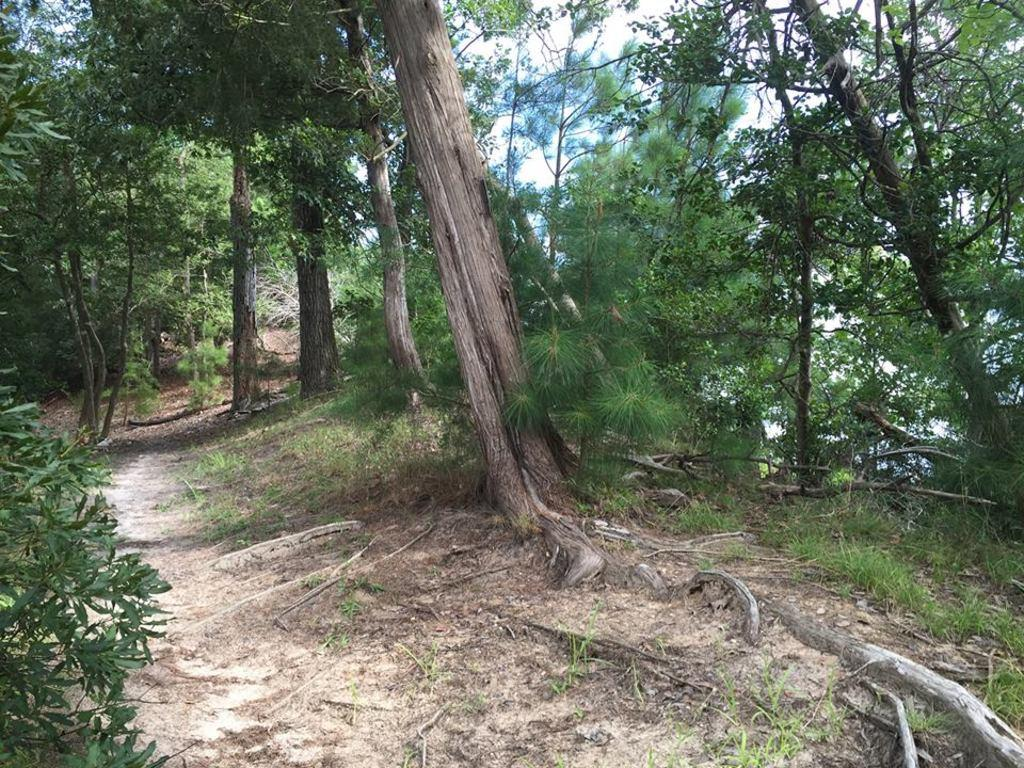What type of ground cover is visible in the image? There is grass on the ground in the image. What type of vegetation is present in the image besides grass? There are many trees in the image. What type of waste can be seen in the image? There is no waste visible in the image; it features grass and trees. How many knots are present in the image? There are no knots present in the image. 